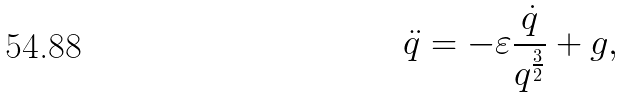Convert formula to latex. <formula><loc_0><loc_0><loc_500><loc_500>\ddot { q } = - \varepsilon \frac { \dot { q } } { q ^ { \frac { 3 } { 2 } } } + g ,</formula> 